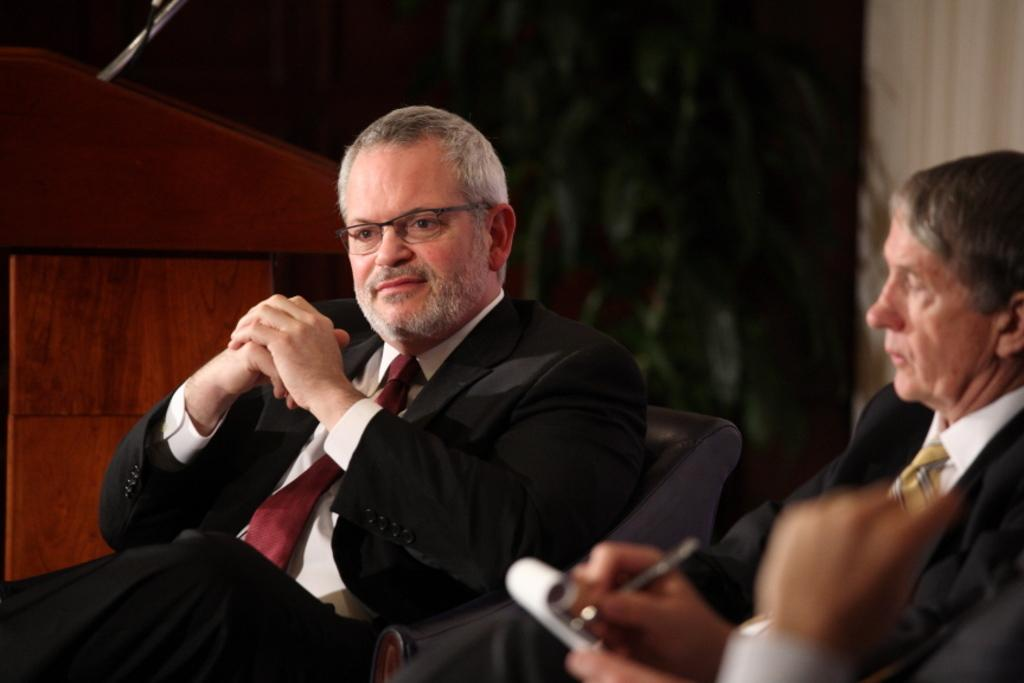How many people are in the image? There are two persons sitting in the center of the image. What is one person doing in the image? One person is holding a pen and paper. What is the person holding the pen and paper doing? The person is writing something. What can be seen in the background of the image? There is a podium and a wall in the background of the image. How many legs does the parcel have in the image? There is no parcel present in the image, so it is not possible to determine how many legs it might have. 